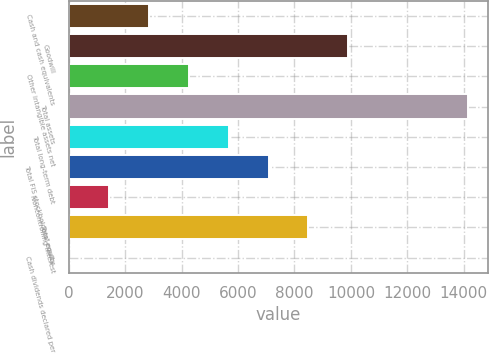Convert chart. <chart><loc_0><loc_0><loc_500><loc_500><bar_chart><fcel>Cash and cash equivalents<fcel>Goodwill<fcel>Other intangible assets net<fcel>Total assets<fcel>Total long-term debt<fcel>Total FIS stockholders' equity<fcel>Noncontrolling interest<fcel>Total equity<fcel>Cash dividends declared per<nl><fcel>2832.52<fcel>9913.32<fcel>4248.68<fcel>14161.8<fcel>5664.84<fcel>7081<fcel>1416.36<fcel>8497.16<fcel>0.2<nl></chart> 